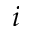Convert formula to latex. <formula><loc_0><loc_0><loc_500><loc_500>i</formula> 